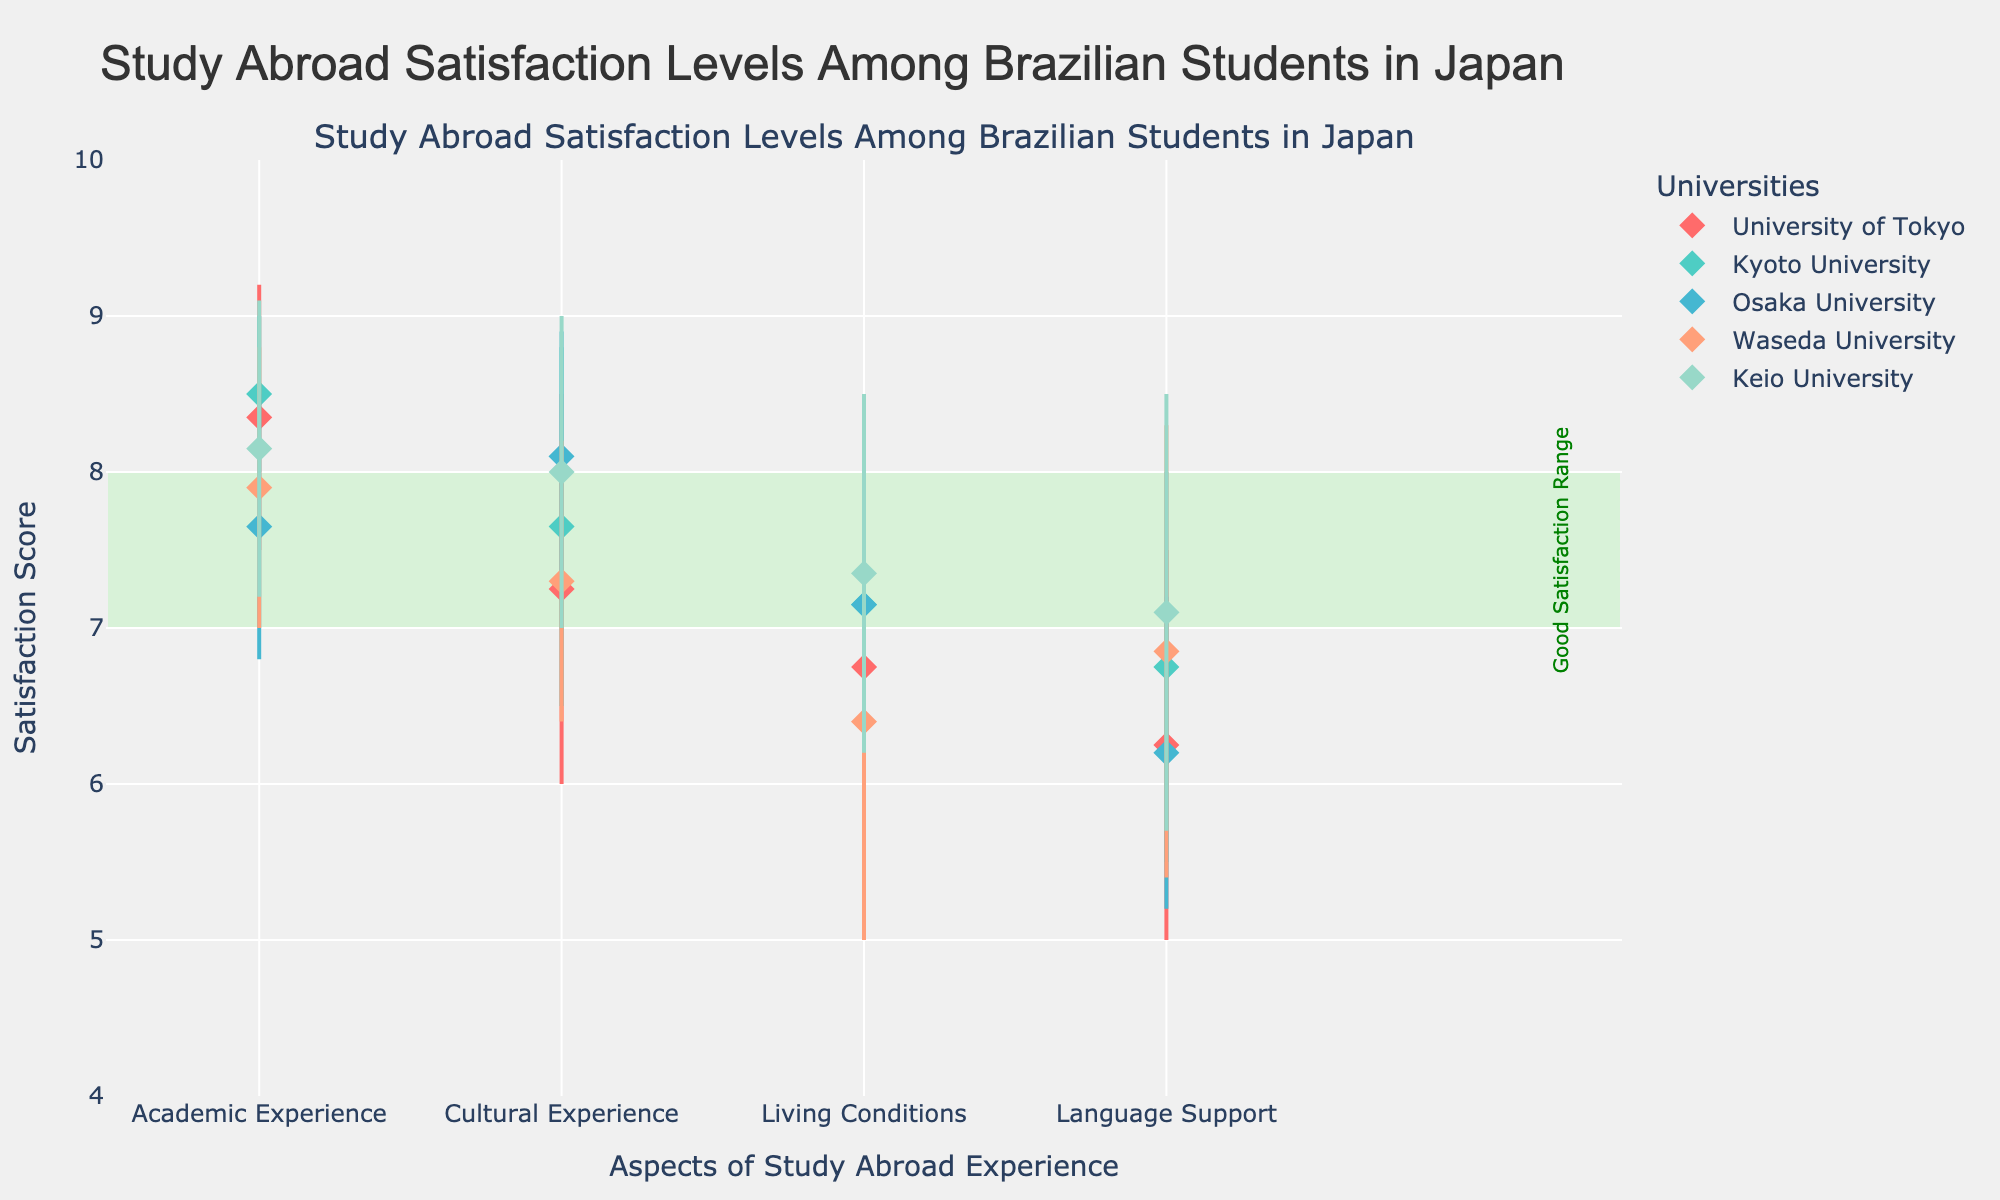What is the highest satisfaction score for Academic Experience at the University of Tokyo? The highest satisfaction score for Academic Experience can be found by identifying the maximum value on the plot for University of Tokyo in this category. It is 9.2.
Answer: 9.2 Which university has the lowest minimum satisfaction score for Language Support? To find the university with the lowest minimum satisfaction score for Language Support, we must look at the minimum satisfaction scores plotted for each university in the Language Support aspect. The University of Tokyo has the lowest minimum score of 5.0.
Answer: University of Tokyo Which university has the widest range of scores for Cultural Experience? To identify the university with the widest range of scores, subtract the minimum score from the maximum score for each university in the Cultural Experience category. Compare these ranges to determine which is the largest. Keio University has a range of 9.0 - 7.0 = 2.0, which is the widest.
Answer: Keio University List all the universities that have a satisfaction score range within the "Good Satisfaction Range" (7-8) for Living Conditions. Identify all universities where the entire range of scores for Living Conditions falls within the 7-8 range. After examining, no university has both minimum and maximum scores entirely within this range.
Answer: None Which university's Cultural Experience has a higher average satisfaction score than its Academic Experience? To determine if a university's Cultural Experience scores higher on average than its Academic Experience, calculate the average (mean) of the min and max scores for both categories and compare. For Kyoto University, Cultural Experience (7.65) is higher than Academic Experience (8.5).
Answer: Kyoto University Between Kyoto University and Keio University, which one has better overall maximum satisfaction scores across all aspects? Compare the maximum satisfaction scores across all aspects for both Kyoto University and Keio University, then sum them up to see which is higher. Kyoto (9.0, 8.8, 8.3, 8.0) = 34.1 and Keio (9.1, 9.0, 8.5, 8.5) = 35.1. Therefore, Keio University has better overall scores.
Answer: Keio University What is the average (mean) of the highest satisfaction scores for Language Support across all universities? Sum the maximum satisfaction scores for Language Support across all universities and divide by the number of universities. (Tokyo 7.5, Kyoto 8.0, Osaka 7.2, Waseda 8.3, Keio 8.5) gives (7.5 + 8.0 + 7.2 + 8.3 + 8.5) / 5 = 7.9.
Answer: 7.9 Which university has the narrowest range of satisfaction scores for Living Conditions? To find the narrowest range, subtract the minimum score from the maximum score for each university in Living Conditions and identify the smallest difference. Keio University has a range of 8.5 - 6.2 = 2.3.
Answer: Keio University 